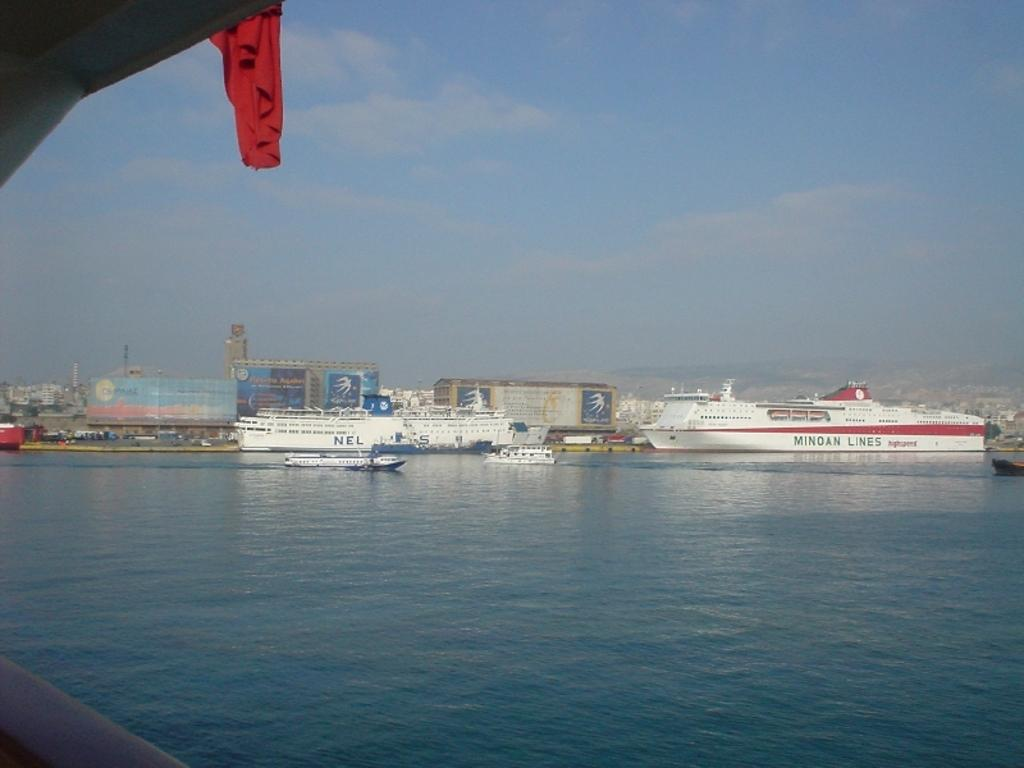What types of vehicles are in the image? There are ships and boats in the image. Where are the ships and boats located? The ships and boats are on the water. What can be seen in the background of the image? There are buildings and the sky visible in the background of the image. What type of pin can be seen holding the stem of the leg in the image? There is no pin, stem, or leg present in the image; it features ships and boats on the water with buildings and the sky in the background. 